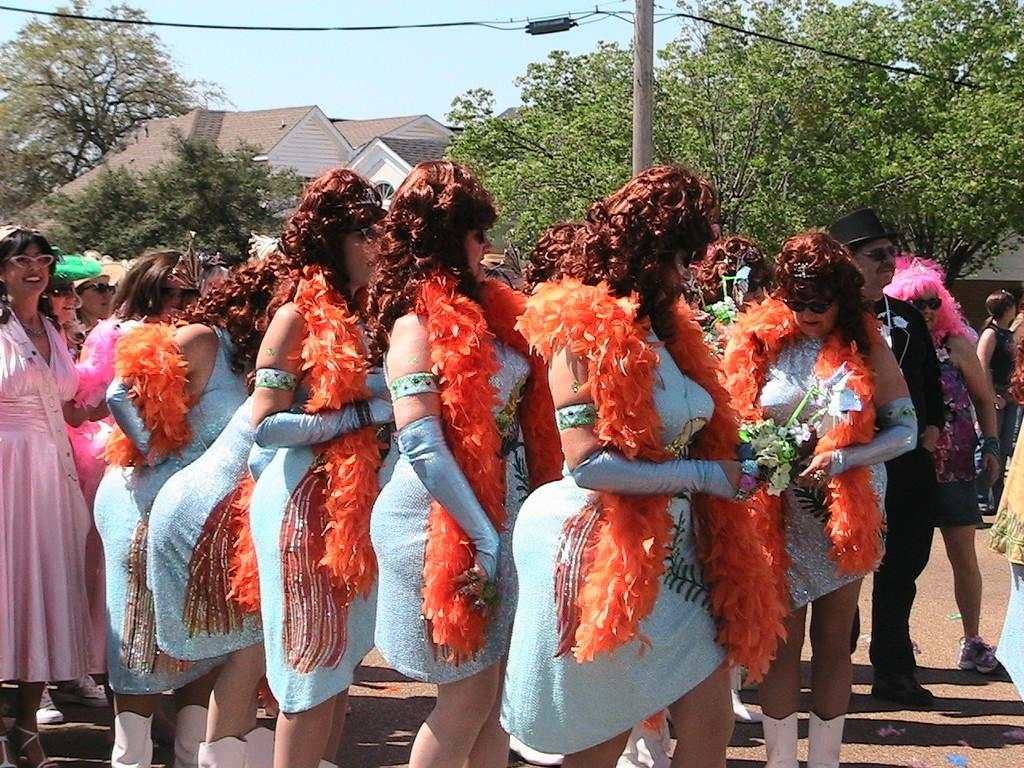What is happening in the image? There are people standing in the image. What can be seen in the background of the image? There are trees and houses visible in the background of the image. What type of haircut does the person in the image have? There is no specific person mentioned in the image, and no haircuts are visible. 